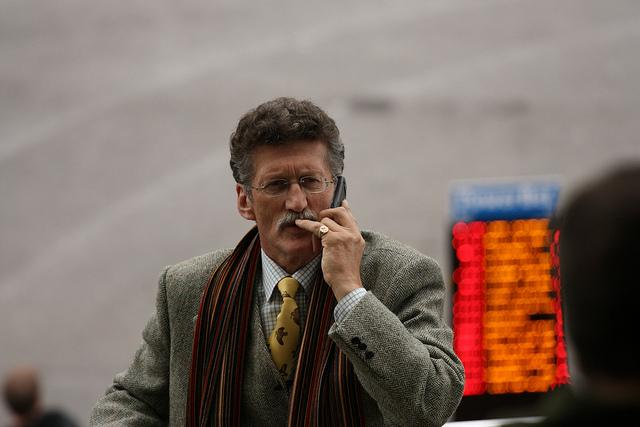What is the man with the mustache doing with the black object? Please explain your reasoning. calling. The man is on the phone talking. 